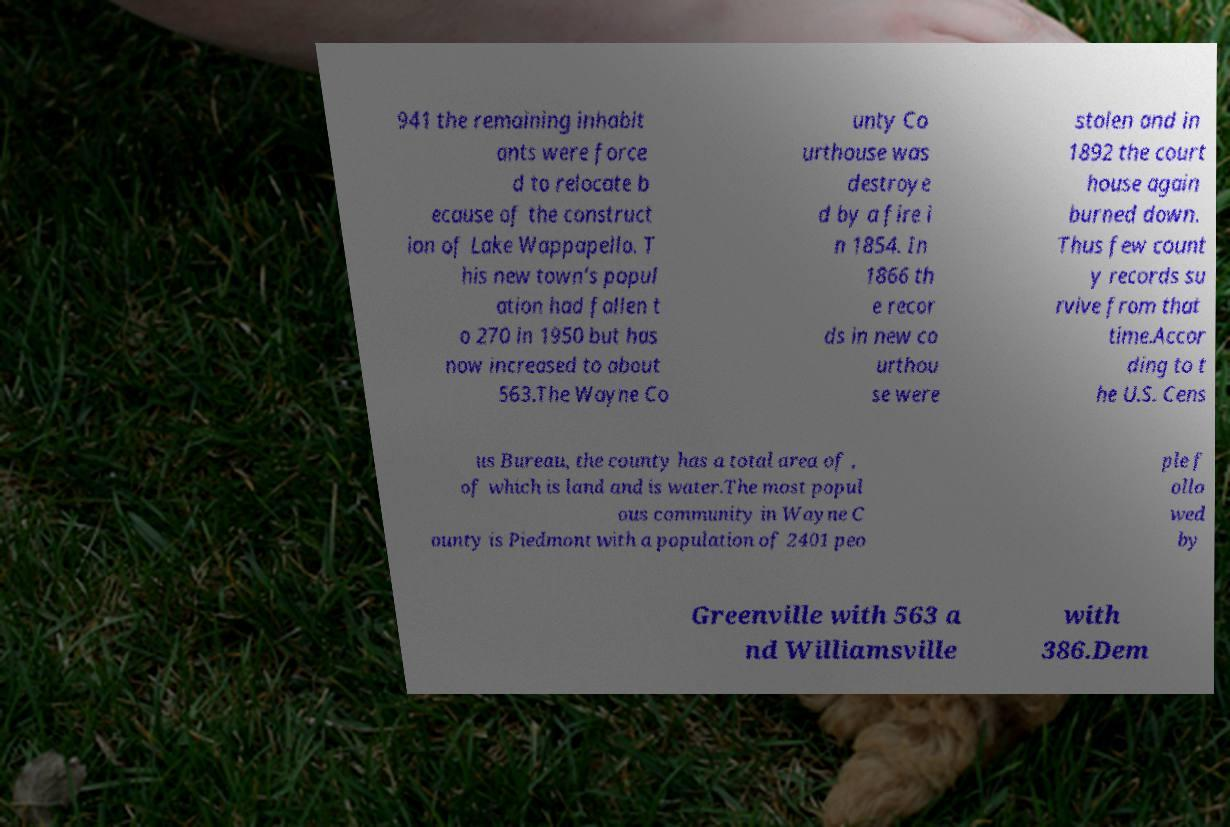What messages or text are displayed in this image? I need them in a readable, typed format. 941 the remaining inhabit ants were force d to relocate b ecause of the construct ion of Lake Wappapello. T his new town's popul ation had fallen t o 270 in 1950 but has now increased to about 563.The Wayne Co unty Co urthouse was destroye d by a fire i n 1854. In 1866 th e recor ds in new co urthou se were stolen and in 1892 the court house again burned down. Thus few count y records su rvive from that time.Accor ding to t he U.S. Cens us Bureau, the county has a total area of , of which is land and is water.The most popul ous community in Wayne C ounty is Piedmont with a population of 2401 peo ple f ollo wed by Greenville with 563 a nd Williamsville with 386.Dem 